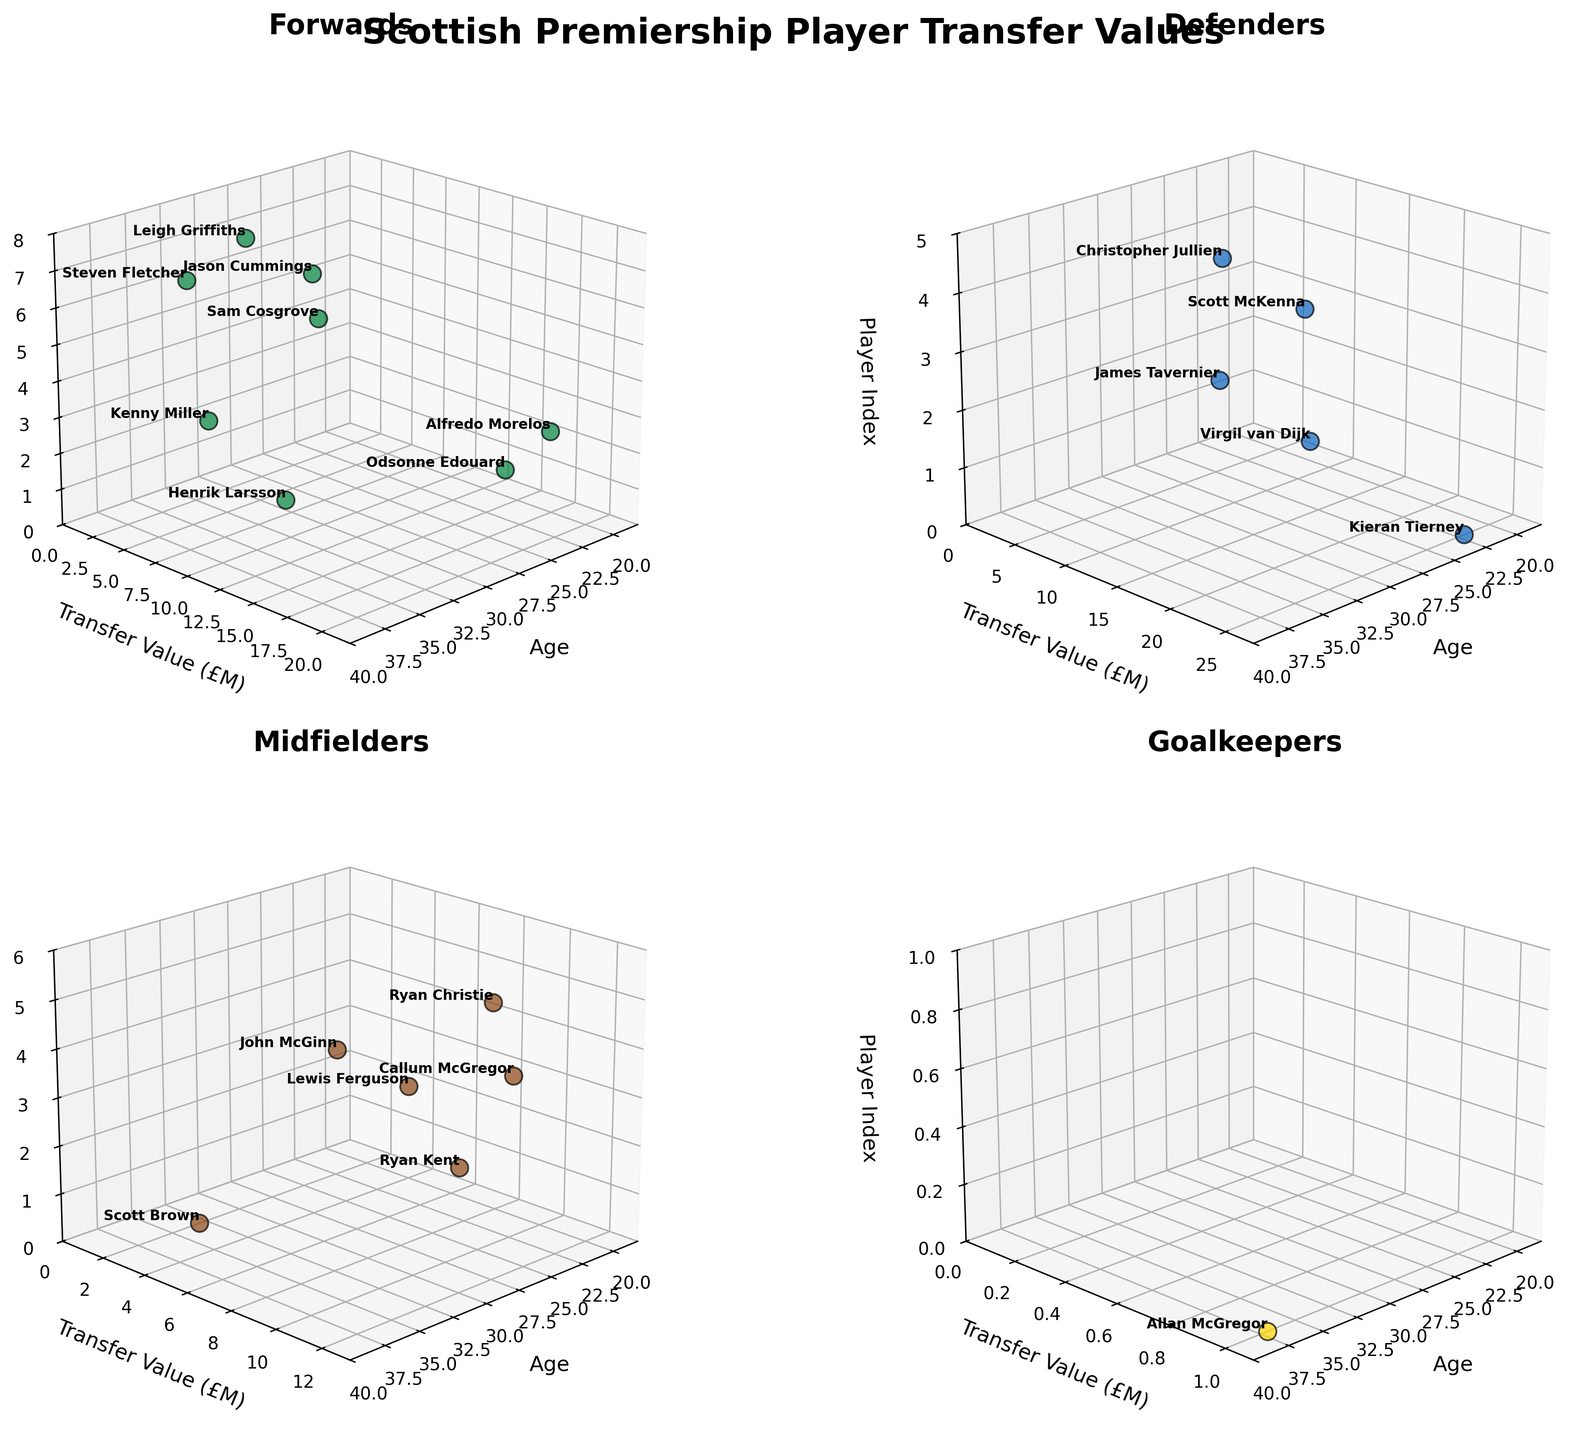What's the title of the figure? Observe the large, bold text at the top center of the figure, which usually indicates the title
Answer: Scottish Premiership Player Transfer Values Which positional subplot contains the player with the highest transfer value? Compare the highest transfer values across the subplots of different positions. The Forward plot contains a £25 million value, which is higher than all other subplots
Answer: Forward How many players aged 24 are listed in the Midfielders plot? Look at the x-axis of the Midfielders plot and count the number of data points (players) at age 24
Answer: 2 Which Defender has the highest Transfer Value, and how old is he? Scan the Defenders subplot and identify the player at the highest y-coordinate. Then, read his corresponding x-coordinate for age and z-index for the player's name (Kieran Tierney, £25 million, age 22)
Answer: Kieran Tierney, 22 What is the average Transfer Value of players aged 22? Identify all players aged 22 across all subplots, sum their transfer values, and divide by the number of these players. Players are Kieran Tierney (£25M), Ryan Kent (£7.5M), Jason Cummings (£1M); so average = (25 + 7.5 + 1) / 3
Answer: £11.17M What is the difference in the Transfer Value between the most expensive Midfielder and the cheapest Goalkeeper? Find the Transfer Value of the most expensive Midfielder and the cheapest Goalkeeper (Ryan Kent £12M and Allan McGregor £1M), and subtract the latter from the former
Answer: £11M Which Forward aged 22 has the lowest Transfer Value? Look at the Forward plot and identify the player at age 22 with the lowest y-coordinate. Jason Cummings has a Transfer Value of £1 million
Answer: Jason Cummings How many players with a Transfer Value above £10 million are in the Defenders plot? Count the number of data points in the Defenders plot that are located above £10 million on the y-axis
Answer: 3 Which subplot has the most players? Compare the number of data points in each positional subplot and see which one has the maximum count. The Midfielders plot has 5 players
Answer: Midfielders Are there more players aged under 25 in the Forward or Midfielder plots? Count the number of players aged under 25 in both the Forward and Midfielder plots and compare. Forwards: 2 (Edouard and Cummings), Midfielders: 2 (Ryan Kent and Lewis Ferguson)
Answer: Equal, both have 2 